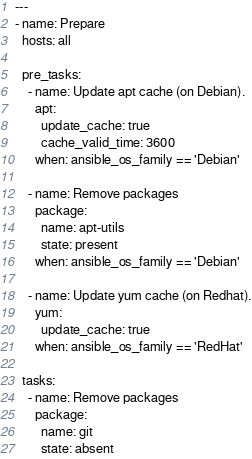Convert code to text. <code><loc_0><loc_0><loc_500><loc_500><_YAML_>---
- name: Prepare
  hosts: all

  pre_tasks:
    - name: Update apt cache (on Debian).
      apt:
        update_cache: true
        cache_valid_time: 3600
      when: ansible_os_family == 'Debian'

    - name: Remove packages
      package:
        name: apt-utils
        state: present
      when: ansible_os_family == 'Debian'

    - name: Update yum cache (on Redhat).
      yum:
        update_cache: true
      when: ansible_os_family == 'RedHat'

  tasks:
    - name: Remove packages
      package:
        name: git
        state: absent
</code> 